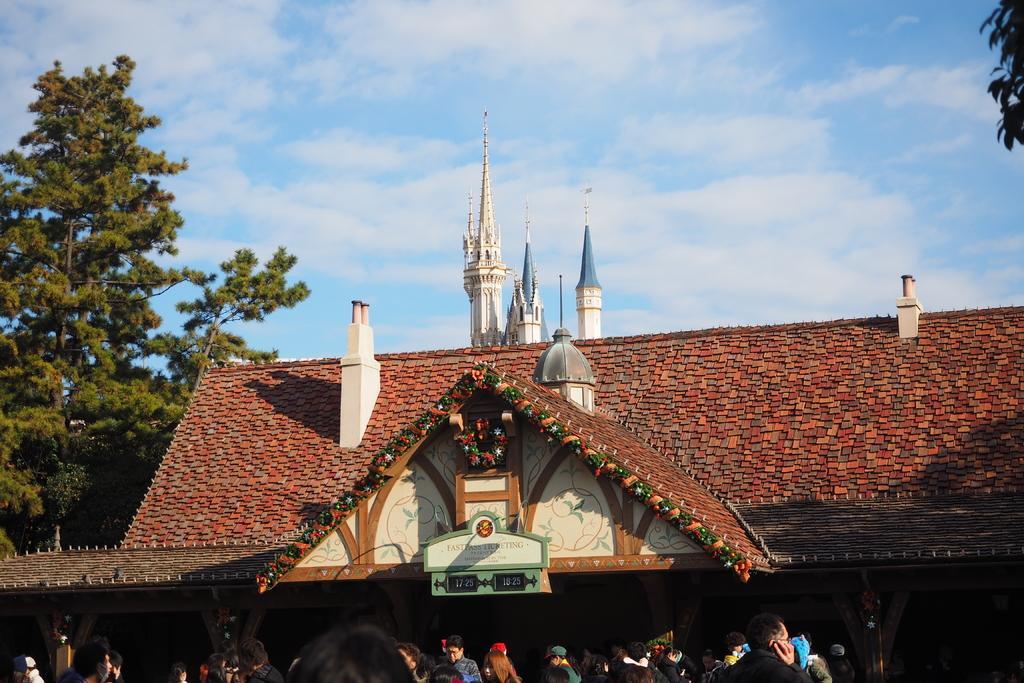Describe this image in one or two sentences. In this image, we can see a house roof, pillars, decorative items. At the bottom, we can see a group of people. Background we can see trees and sky. 